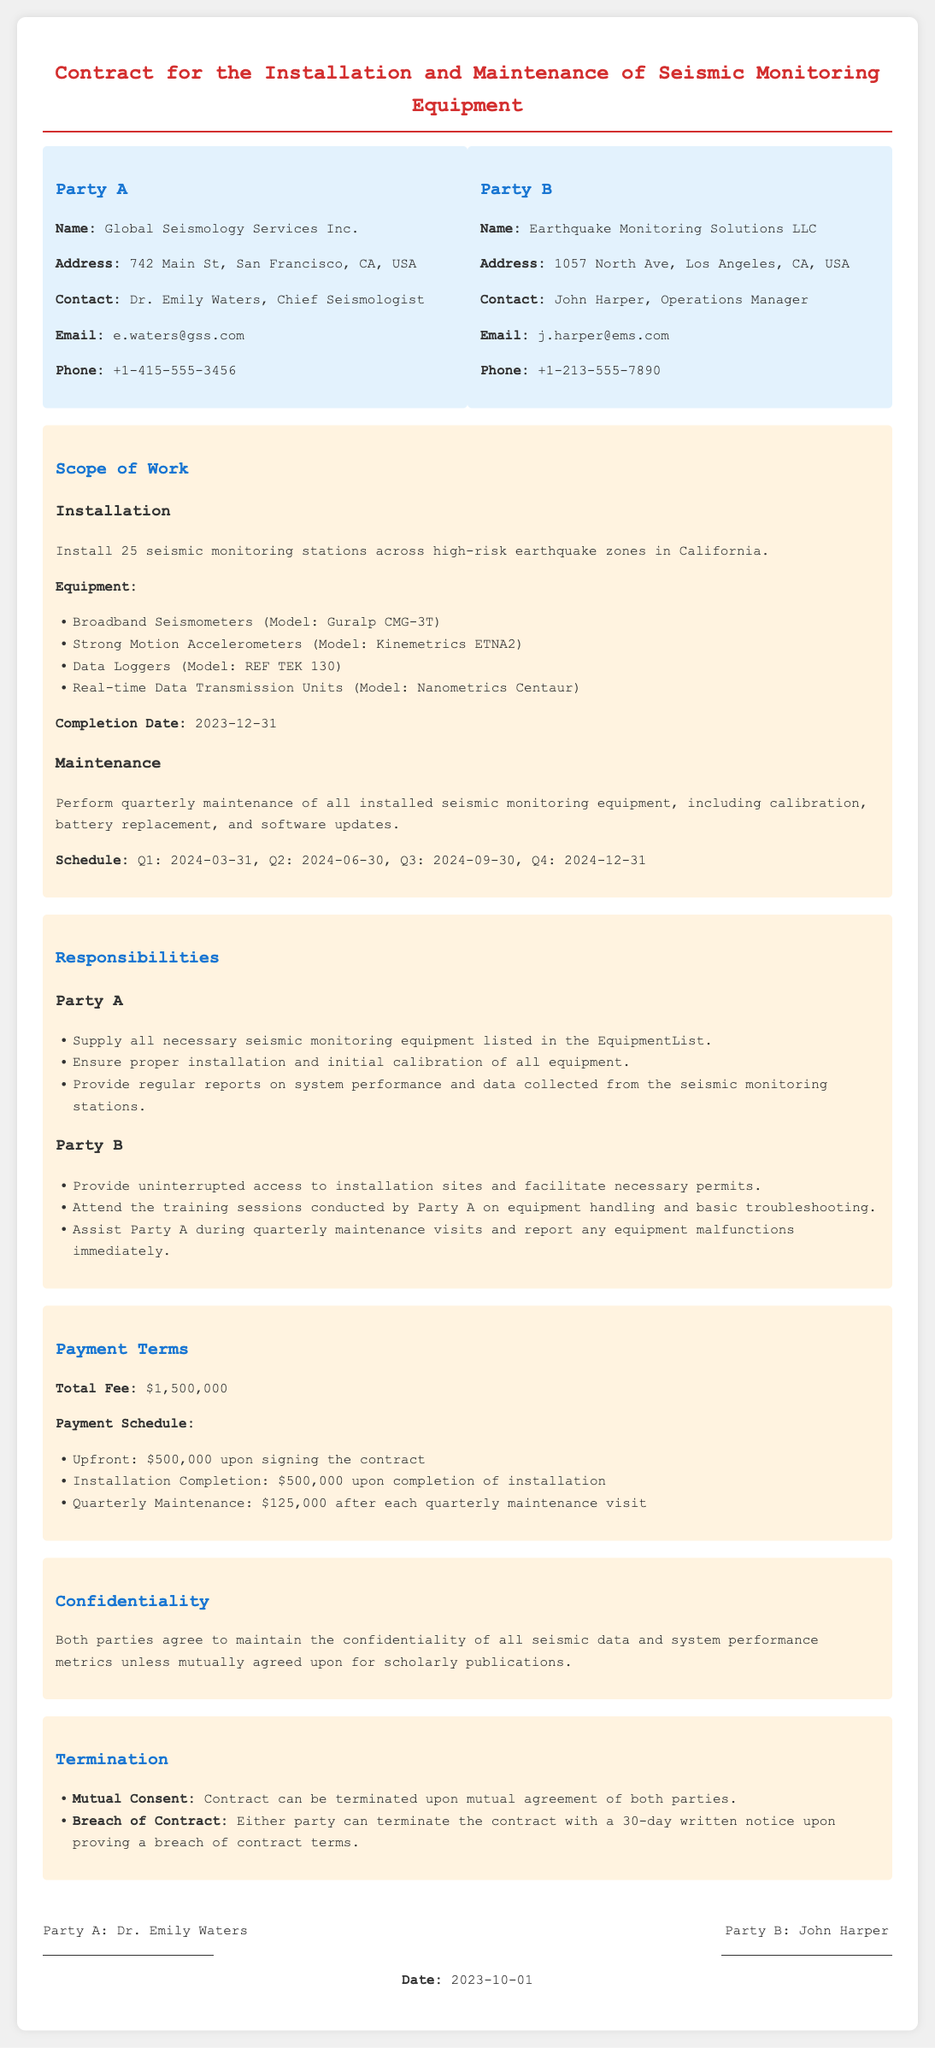What is the name of Party A? Party A is identified as Global Seismology Services Inc. in the contract.
Answer: Global Seismology Services Inc What is the address of Party B? The address of Party B, Earthquake Monitoring Solutions LLC, is specified in the document.
Answer: 1057 North Ave, Los Angeles, CA, USA What is the total fee for the contract? The total fee is clearly stated in the payment terms section of the document.
Answer: $1,500,000 What is the completion date for the installation? The document specifies a completion date for the installation section.
Answer: 2023-12-31 How often will maintenance be performed? The maintenance schedule frequency is mentioned in the maintenance section.
Answer: Quarterly Who is the contact for Party B? The contract provides the contact person's name for Party B.
Answer: John Harper What equipment will be installed according to the contract? The contract lists specific equipment under the installation scope.
Answer: Broadband Seismometers, Strong Motion Accelerometers, Data Loggers, Real-time Data Transmission Units What is the notification period for breach of contract termination? The contract describes the notification period required for termination due to breach.
Answer: 30-day written notice What is stated about confidentiality in the document? The confidentiality section outlines the agreements regarding data confidentiality.
Answer: Maintain confidentiality of all seismic data and system performance metrics 